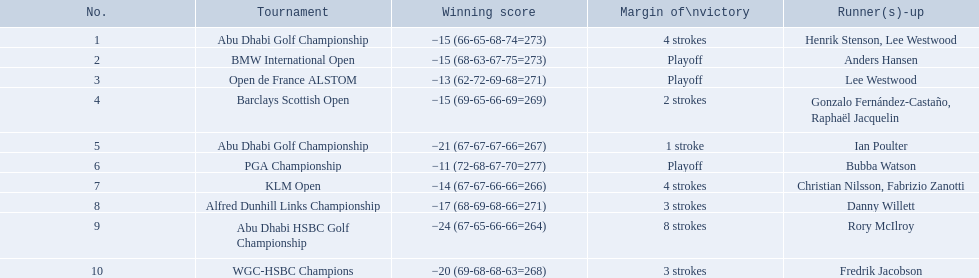What were all of the tournaments martin played in? Abu Dhabi Golf Championship, BMW International Open, Open de France ALSTOM, Barclays Scottish Open, Abu Dhabi Golf Championship, PGA Championship, KLM Open, Alfred Dunhill Links Championship, Abu Dhabi HSBC Golf Championship, WGC-HSBC Champions. And how many strokes did he score? −15 (66-65-68-74=273), −15 (68-63-67-75=273), −13 (62-72-69-68=271), −15 (69-65-66-69=269), −21 (67-67-67-66=267), −11 (72-68-67-70=277), −14 (67-67-66-66=266), −17 (68-69-68-66=271), −24 (67-65-66-66=264), −20 (69-68-68-63=268). What about during barclays and klm? −15 (69-65-66-69=269), −14 (67-67-66-66=266). How many more were scored in klm? 2 strokes. 